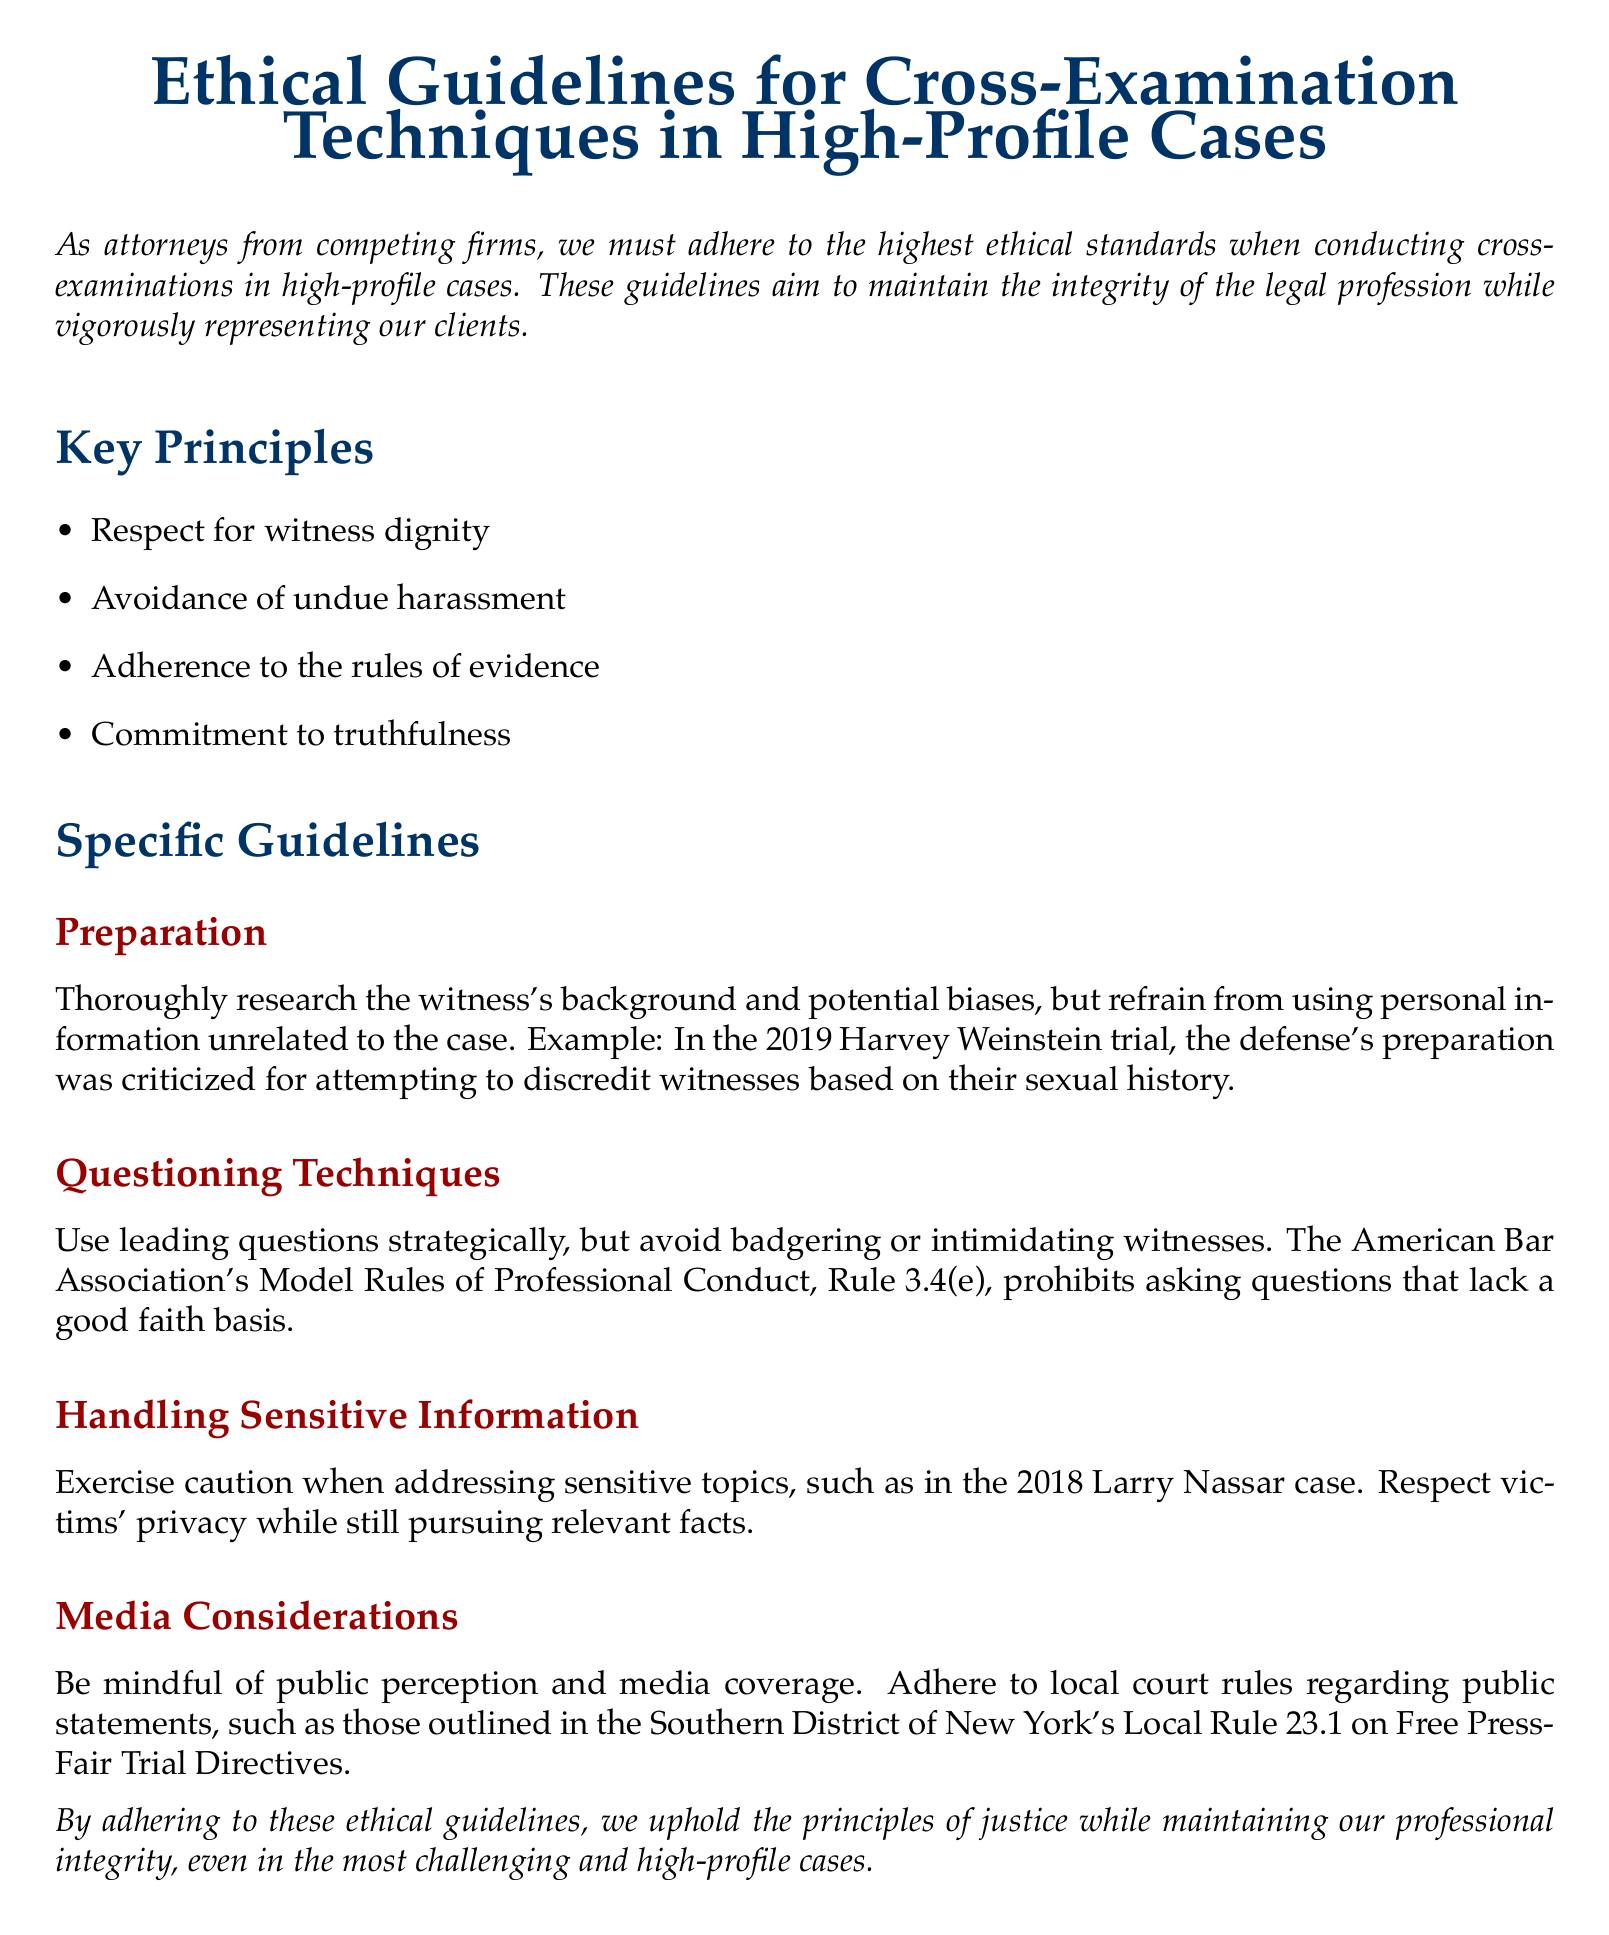What is the title of the document? The title of the document is presented in a large font at the top, indicating its subject matter.
Answer: Ethical Guidelines for Cross-Examination Techniques in High-Profile Cases What is one of the key principles mentioned? The section on Key Principles lists several principles that guide attorneys, providing insight into the ethical framework.
Answer: Respect for witness dignity Which case is referenced as an example of criticized defense preparation? The document provides a specific example from a high-profile case to illustrate the importance of ethical conduct.
Answer: 2019 Harvey Weinstein trial What rule prohibits asking questions that lack a good faith basis? The document cites a specific rule to underscore the ethical obligations of attorneys in their questioning techniques.
Answer: Rule 3.4(e) What should attorneys be cautious about when addressing sensitive topics? This guideline emphasizes the need for attorneys to protect certain aspects during cross-examinations.
Answer: Victims' privacy What is one of the media considerations mentioned in the guidelines? The guidelines explicitly remind attorneys to be aware of their conduct in relation to public perception and media coverage.
Answer: Adhere to local court rules How many key principles are listed in the document? The document details a list of ethical principles guiding cross-examinations, directly indicating the count.
Answer: Four What year is associated with the Larry Nassar case in the document? The document uses this case as a context to highlight the importance of handling sensitive information.
Answer: 2018 